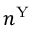<formula> <loc_0><loc_0><loc_500><loc_500>n ^ { Y }</formula> 